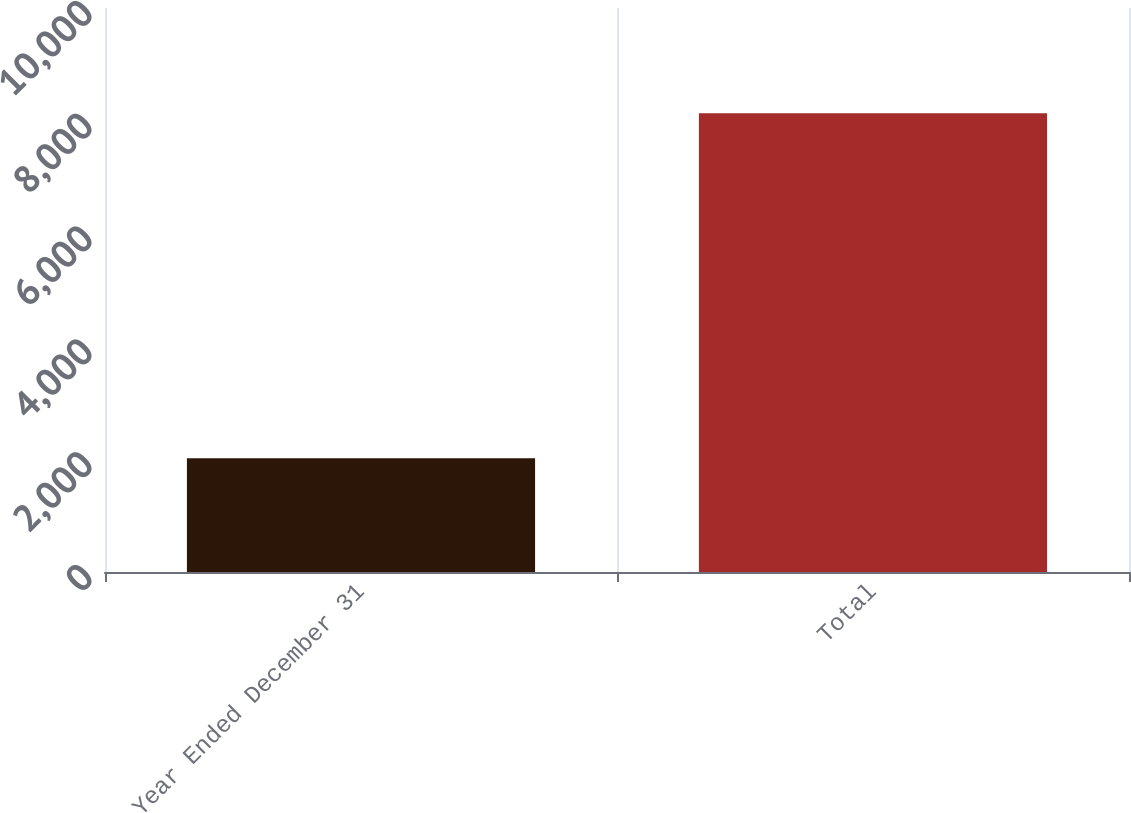Convert chart. <chart><loc_0><loc_0><loc_500><loc_500><bar_chart><fcel>Year Ended December 31<fcel>Total<nl><fcel>2016<fcel>8136<nl></chart> 